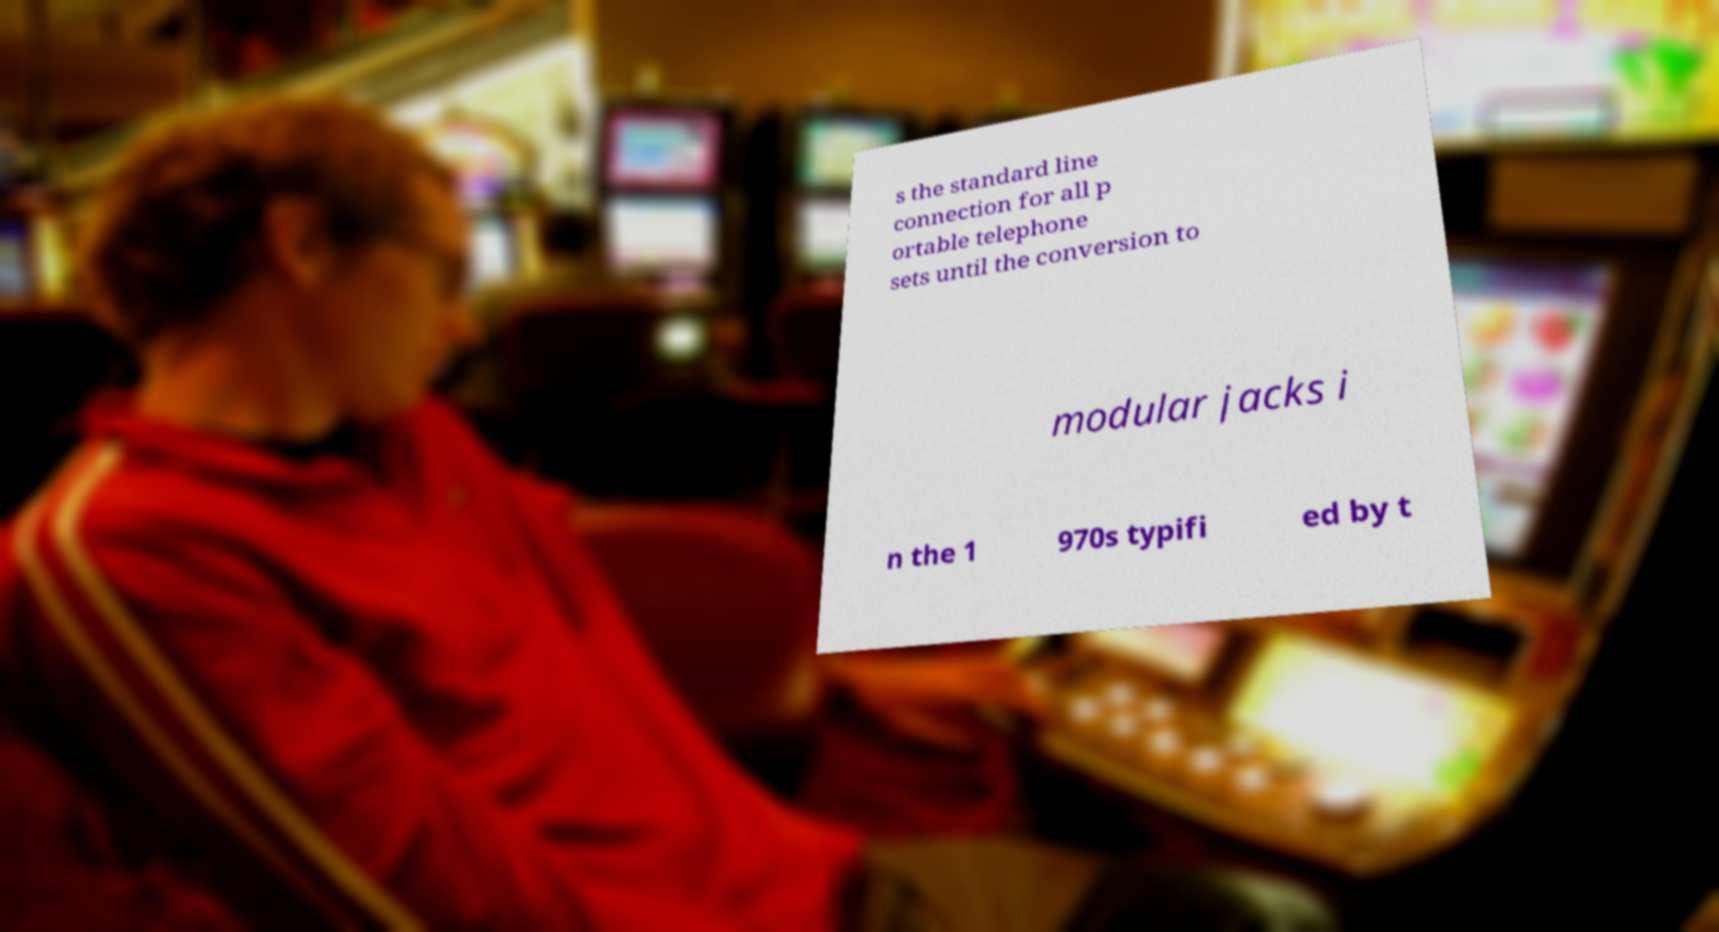There's text embedded in this image that I need extracted. Can you transcribe it verbatim? s the standard line connection for all p ortable telephone sets until the conversion to modular jacks i n the 1 970s typifi ed by t 